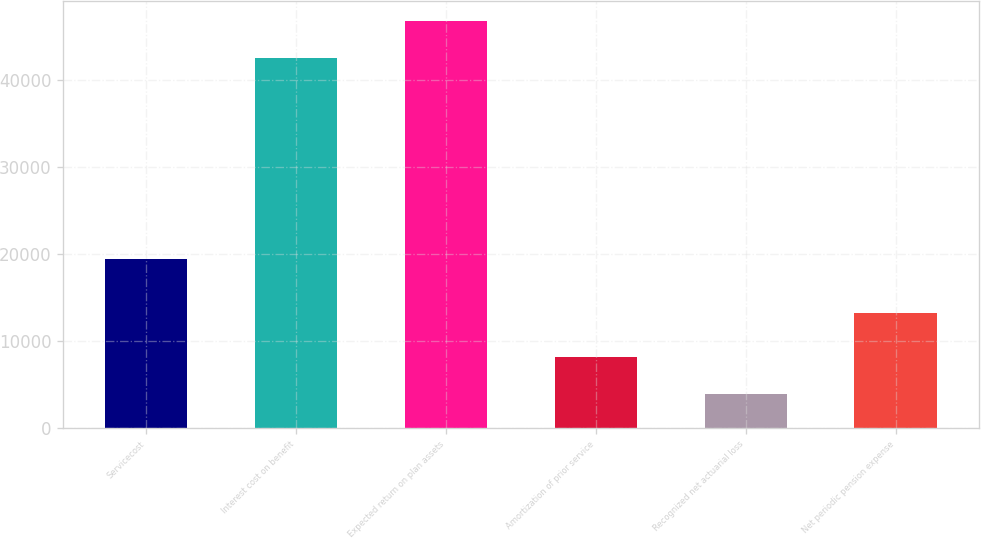Convert chart. <chart><loc_0><loc_0><loc_500><loc_500><bar_chart><fcel>Servicecost<fcel>Interest cost on benefit<fcel>Expected return on plan assets<fcel>Amortization of prior service<fcel>Recognized net actuarial loss<fcel>Net periodic pension expense<nl><fcel>19409<fcel>42544<fcel>46759<fcel>8157<fcel>3942<fcel>13244<nl></chart> 